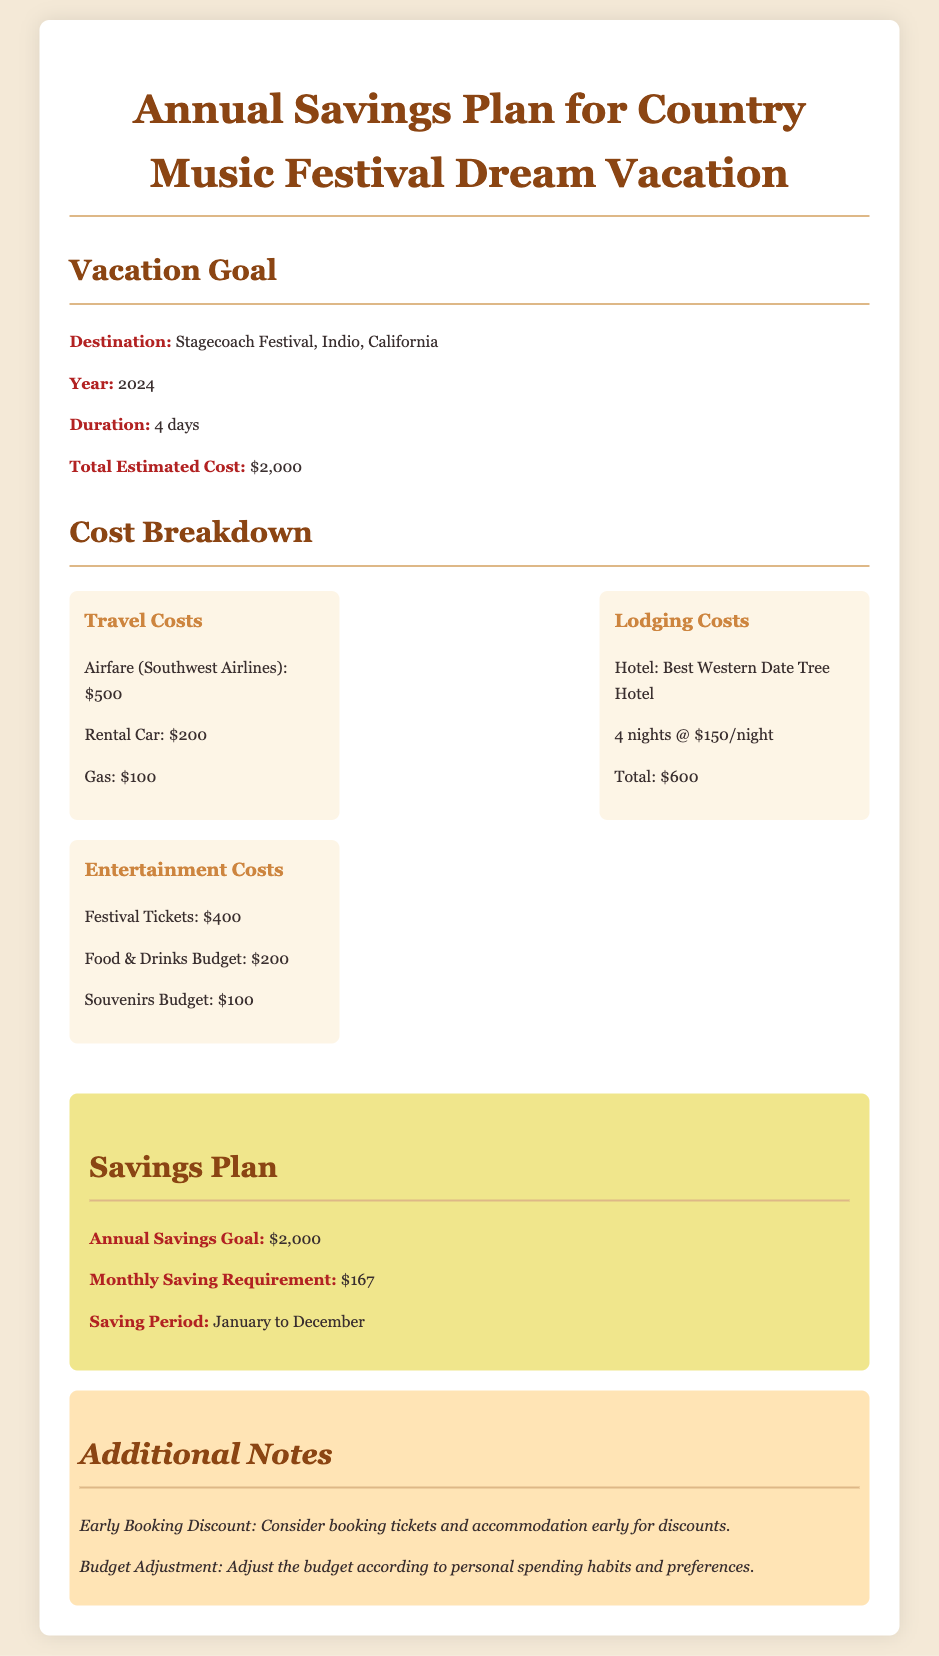what is the destination of the vacation? The document specifies the destination as Stagecoach Festival in Indio, California.
Answer: Stagecoach Festival, Indio, California what is the total estimated cost of the vacation? The total estimated cost mentioned in the document is $2,000.
Answer: $2,000 how much is the airfare with Southwest Airlines? The airfare cost for Southwest Airlines is indicated as $500 in the cost breakdown.
Answer: $500 how long is the duration of the vacation? The duration of the vacation is clearly outlined as 4 days.
Answer: 4 days what is the monthly saving requirement? The document states that the monthly saving requirement is $167 to meet the annual savings goal.
Answer: $167 how much money is allocated for food and drinks? The cost breakdown lists the food and drinks budget at $200.
Answer: $200 what is the name of the hotel for lodging? The lodging section specifies the hotel as Best Western Date Tree Hotel.
Answer: Best Western Date Tree Hotel what is the saving period for the vacation? The document states that the saving period is from January to December.
Answer: January to December what should be considered for early discounts? The document notes to consider booking tickets and accommodation early for discounts.
Answer: Booking tickets and accommodation early what is the total lodging cost for the hotel? According to the cost breakdown, the total lodging cost is $600 based on the duration and price per night.
Answer: $600 